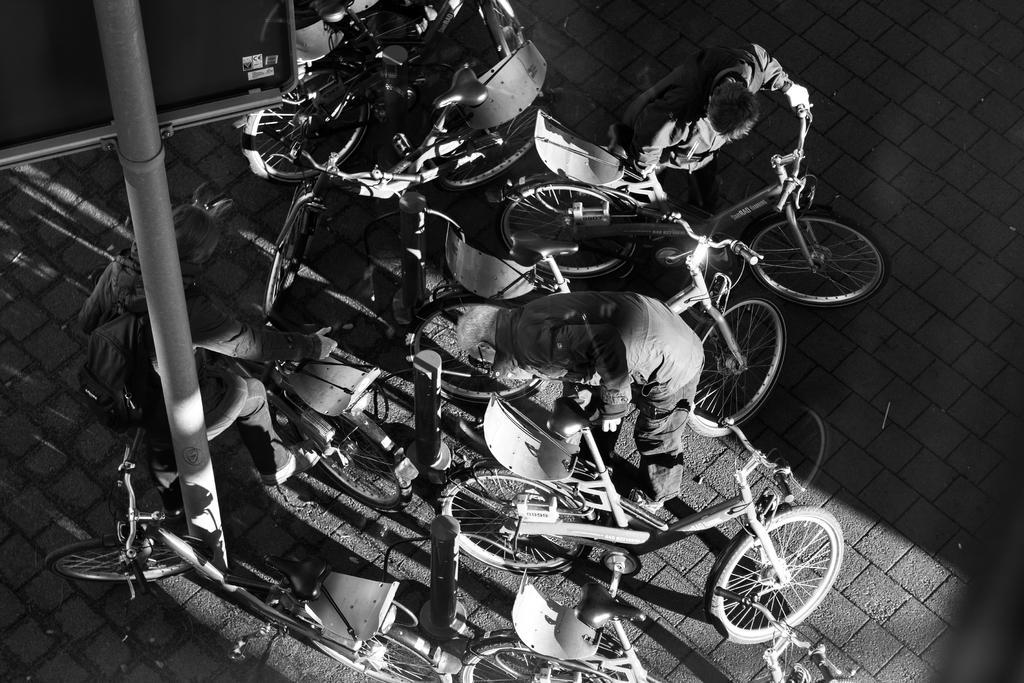Describe this image in one or two sentences. Black and white picture. In this picture we can see bicycles, people, pole and board. 